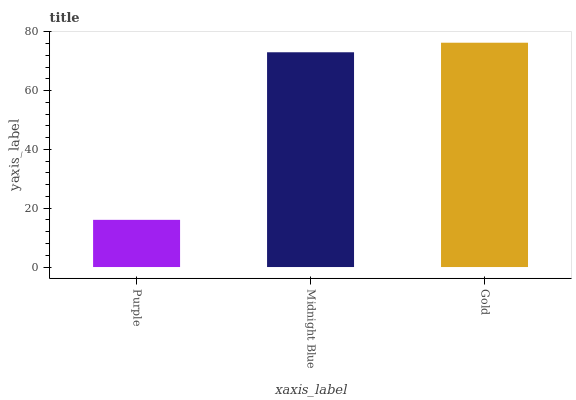Is Purple the minimum?
Answer yes or no. Yes. Is Gold the maximum?
Answer yes or no. Yes. Is Midnight Blue the minimum?
Answer yes or no. No. Is Midnight Blue the maximum?
Answer yes or no. No. Is Midnight Blue greater than Purple?
Answer yes or no. Yes. Is Purple less than Midnight Blue?
Answer yes or no. Yes. Is Purple greater than Midnight Blue?
Answer yes or no. No. Is Midnight Blue less than Purple?
Answer yes or no. No. Is Midnight Blue the high median?
Answer yes or no. Yes. Is Midnight Blue the low median?
Answer yes or no. Yes. Is Purple the high median?
Answer yes or no. No. Is Gold the low median?
Answer yes or no. No. 